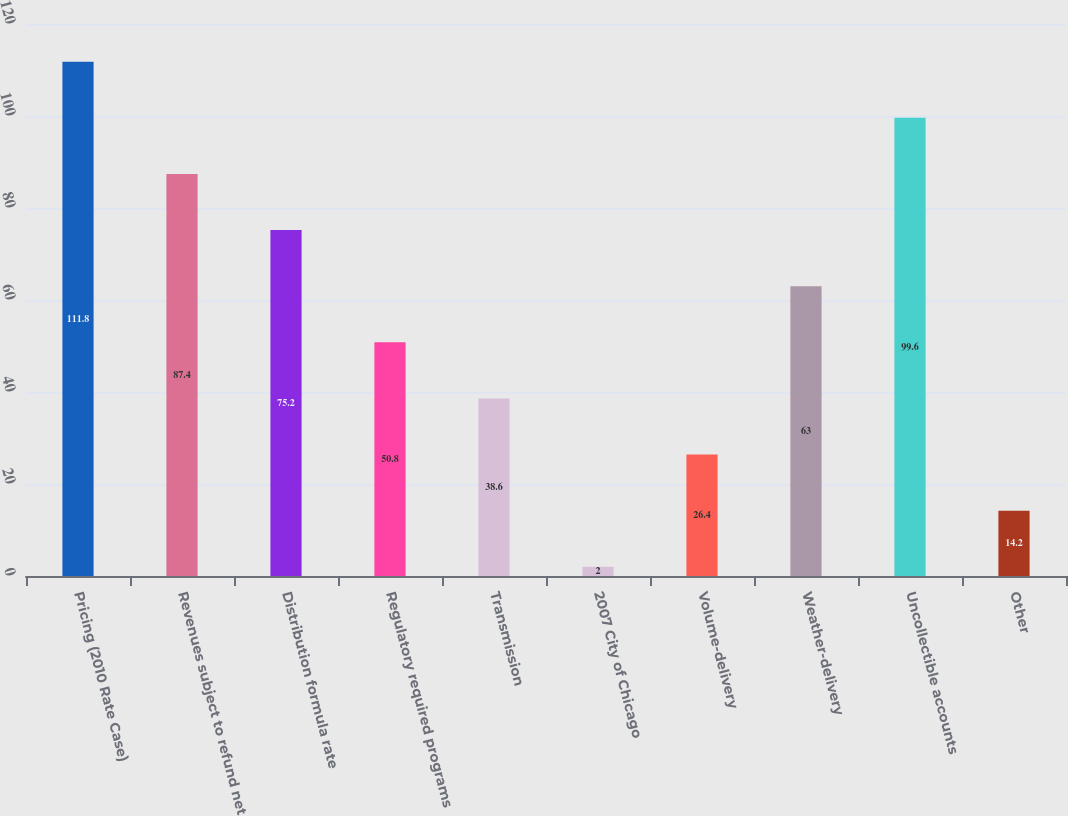Convert chart to OTSL. <chart><loc_0><loc_0><loc_500><loc_500><bar_chart><fcel>Pricing (2010 Rate Case)<fcel>Revenues subject to refund net<fcel>Distribution formula rate<fcel>Regulatory required programs<fcel>Transmission<fcel>2007 City of Chicago<fcel>Volume-delivery<fcel>Weather-delivery<fcel>Uncollectible accounts<fcel>Other<nl><fcel>111.8<fcel>87.4<fcel>75.2<fcel>50.8<fcel>38.6<fcel>2<fcel>26.4<fcel>63<fcel>99.6<fcel>14.2<nl></chart> 